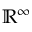Convert formula to latex. <formula><loc_0><loc_0><loc_500><loc_500>\mathbb { R } ^ { \infty }</formula> 